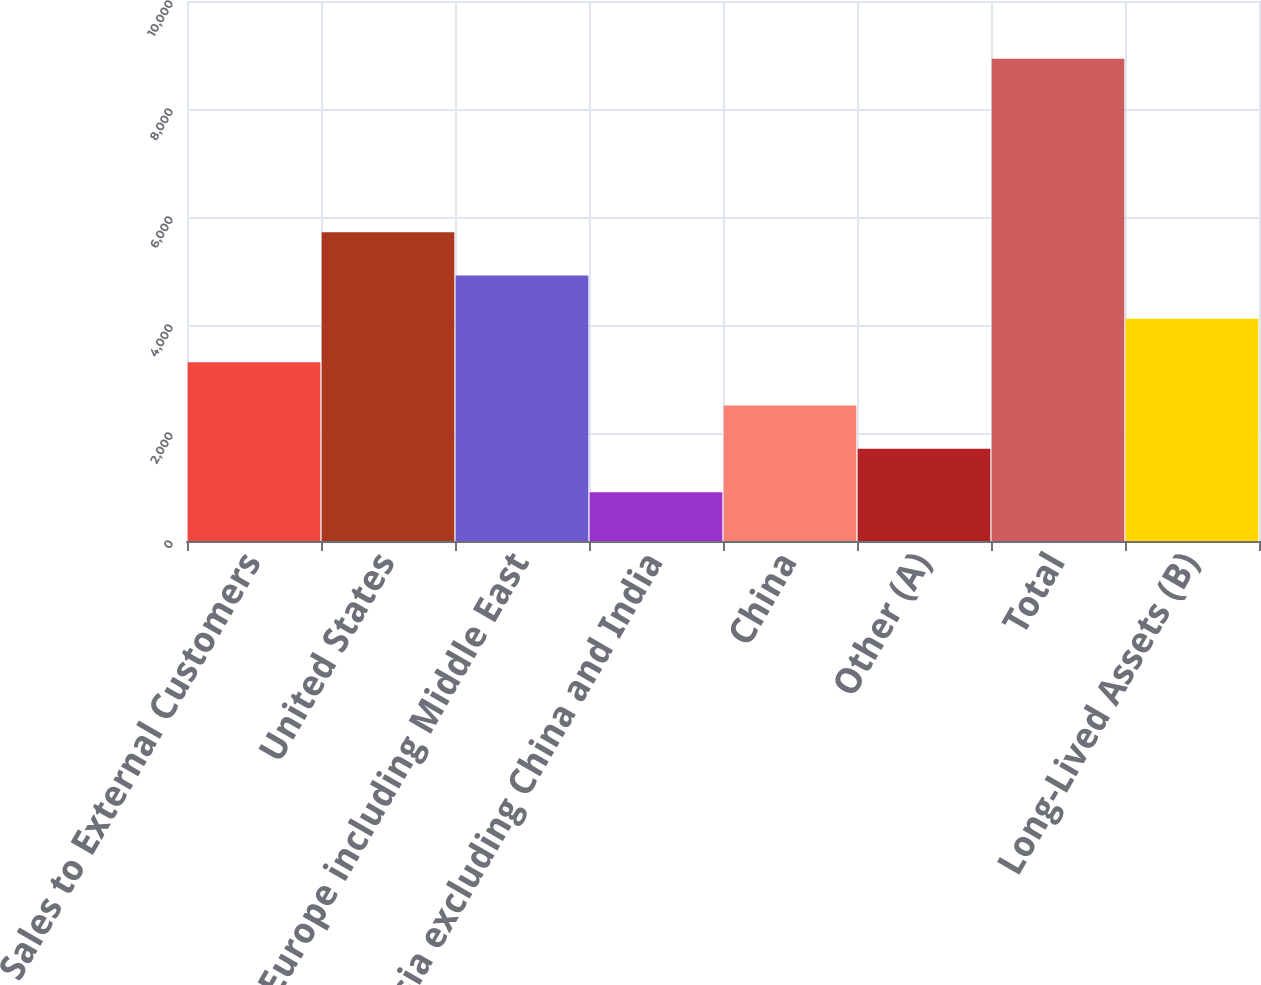<chart> <loc_0><loc_0><loc_500><loc_500><bar_chart><fcel>Sales to External Customers<fcel>United States<fcel>Europe including Middle East<fcel>Asia excluding China and India<fcel>China<fcel>Other (A)<fcel>Total<fcel>Long-Lived Assets (B)<nl><fcel>3311.86<fcel>5719.72<fcel>4917.1<fcel>904<fcel>2509.24<fcel>1706.62<fcel>8930.2<fcel>4114.48<nl></chart> 